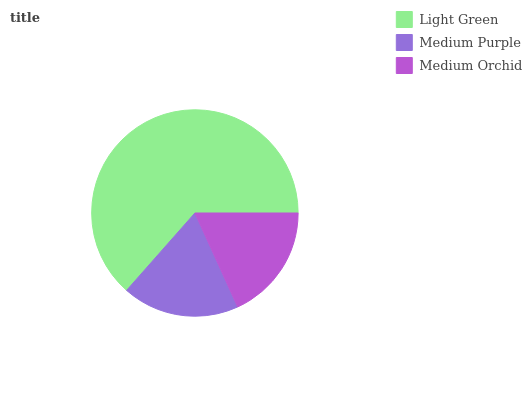Is Medium Orchid the minimum?
Answer yes or no. Yes. Is Light Green the maximum?
Answer yes or no. Yes. Is Medium Purple the minimum?
Answer yes or no. No. Is Medium Purple the maximum?
Answer yes or no. No. Is Light Green greater than Medium Purple?
Answer yes or no. Yes. Is Medium Purple less than Light Green?
Answer yes or no. Yes. Is Medium Purple greater than Light Green?
Answer yes or no. No. Is Light Green less than Medium Purple?
Answer yes or no. No. Is Medium Purple the high median?
Answer yes or no. Yes. Is Medium Purple the low median?
Answer yes or no. Yes. Is Medium Orchid the high median?
Answer yes or no. No. Is Medium Orchid the low median?
Answer yes or no. No. 